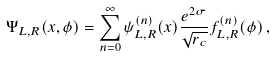Convert formula to latex. <formula><loc_0><loc_0><loc_500><loc_500>\Psi _ { L , R } ( x , \phi ) = \sum _ { n = 0 } ^ { \infty } \psi ^ { ( n ) } _ { L , R } ( x ) \frac { e ^ { 2 \sigma } } { \sqrt { r _ { c } } } f ^ { ( n ) } _ { L , R } ( \phi ) \, ,</formula> 